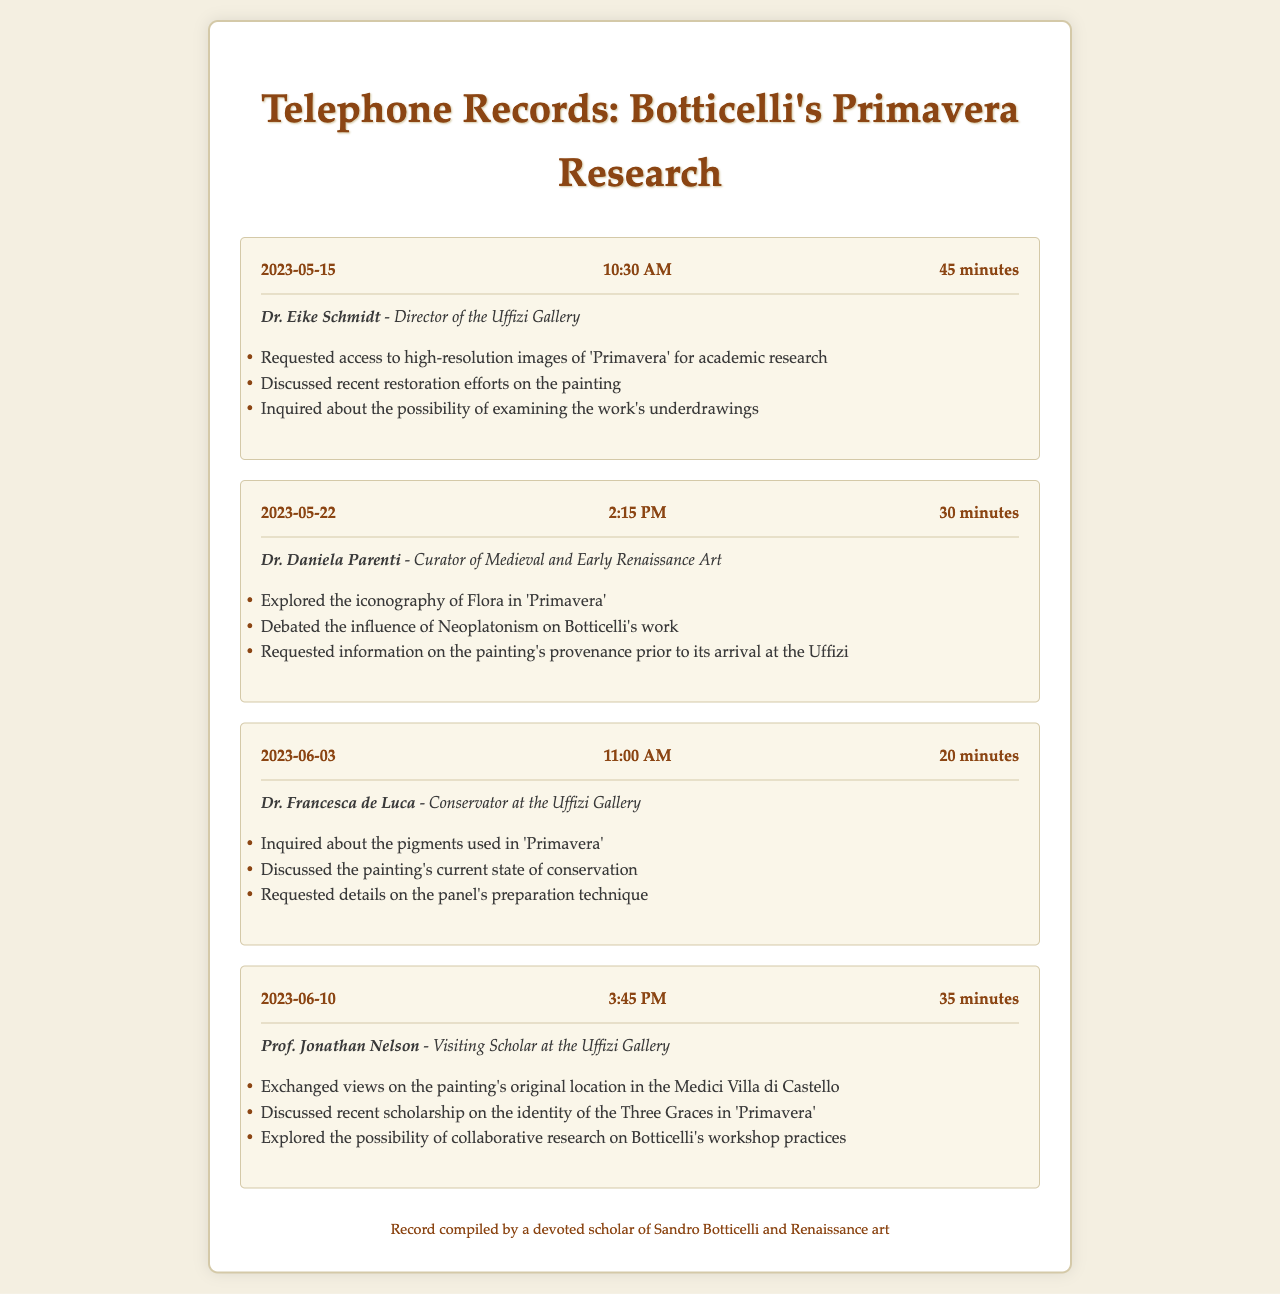what is the date of the first call? The date of the first call is clearly stated in the document as May 15, 2023.
Answer: May 15, 2023 who did the second call involve? The second call was with Dr. Daniela Parenti, as specified in the contact information of the call record.
Answer: Dr. Daniela Parenti how long was the third call? The call duration for the third call is mentioned as 20 minutes.
Answer: 20 minutes what topic was discussed in the last call? The last call involved exploration of collaborative research on Botticelli's workshop practices, indicated in the topics of the call.
Answer: Collaborative research on Botticelli's workshop practices which conservator was contacted about the pigments used in 'Primavera'? The document states that Dr. Francesca de Luca, the Conservator at the Uffizi Gallery, was contacted about the pigments.
Answer: Dr. Francesca de Luca how many calls were made in total? The document outlines a total of four call records related to Botticelli's 'Primavera'.
Answer: Four what was the focus of the call with Dr. Eike Schmidt? The focus of Dr. Eike Schmidt's call was on accessing high-resolution images and recent restoration efforts, indicating the main purpose is academic research.
Answer: Access to high-resolution images and recent restoration efforts what position does Prof. Jonathan Nelson hold? Prof. Jonathan Nelson is listed as a Visiting Scholar at the Uffizi Gallery in the document.
Answer: Visiting Scholar what type of information was requested from Dr. Daniela Parenti? The information requested includes the painting's provenance prior to its arrival at the Uffizi, which represents an inquiry into its historical context.
Answer: Painting's provenance prior to its arrival at the Uffizi 